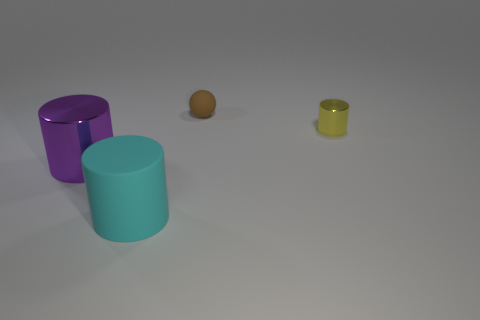What number of things are balls or purple objects that are in front of the yellow metallic cylinder? There is one purple cylinder and one brown ball in front of the yellow metallic cylinder, making a total of 2 objects that fit the description. 